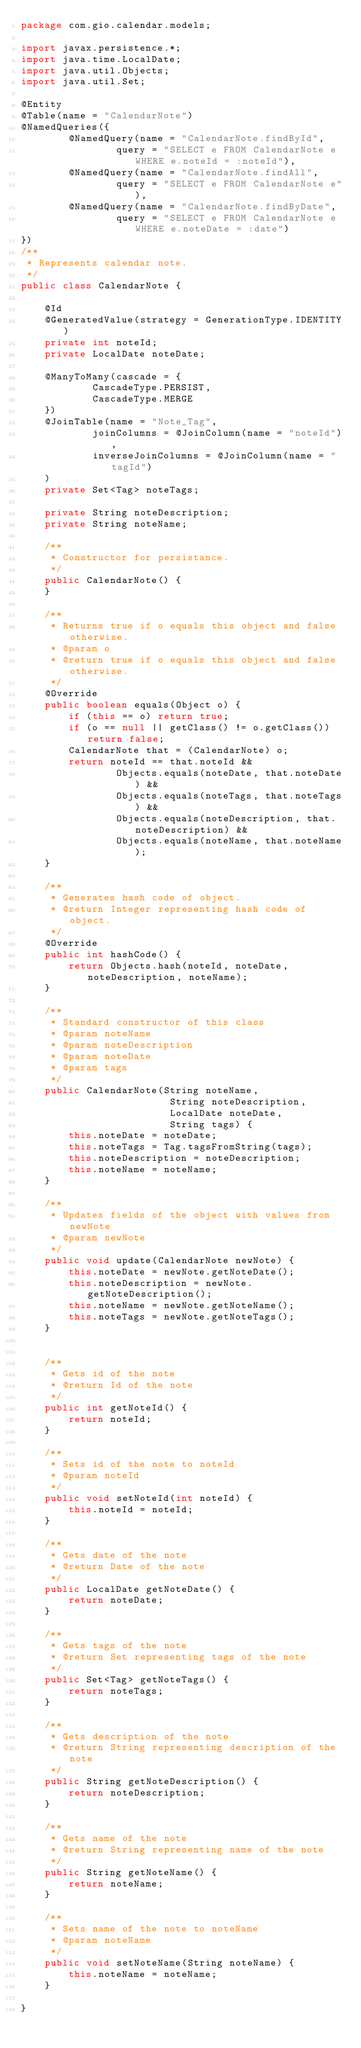Convert code to text. <code><loc_0><loc_0><loc_500><loc_500><_Java_>package com.gio.calendar.models;

import javax.persistence.*;
import java.time.LocalDate;
import java.util.Objects;
import java.util.Set;

@Entity
@Table(name = "CalendarNote")
@NamedQueries({
        @NamedQuery(name = "CalendarNote.findById",
                query = "SELECT e FROM CalendarNote e WHERE e.noteId = :noteId"),
        @NamedQuery(name = "CalendarNote.findAll",
                query = "SELECT e FROM CalendarNote e"),
        @NamedQuery(name = "CalendarNote.findByDate",
                query = "SELECT e FROM CalendarNote e WHERE e.noteDate = :date")
})
/**
 * Represents calendar note.
 */
public class CalendarNote {

    @Id
    @GeneratedValue(strategy = GenerationType.IDENTITY)
    private int noteId;
    private LocalDate noteDate;

    @ManyToMany(cascade = {
            CascadeType.PERSIST,
            CascadeType.MERGE
    })
    @JoinTable(name = "Note_Tag",
            joinColumns = @JoinColumn(name = "noteId"),
            inverseJoinColumns = @JoinColumn(name = "tagId")
    )
    private Set<Tag> noteTags;

    private String noteDescription;
    private String noteName;

    /**
     * Constructor for persistance.
     */
    public CalendarNote() {
    }

    /**
     * Returns true if o equals this object and false otherwise.
     * @param o
     * @return true if o equals this object and false otherwise.
     */
    @Override
    public boolean equals(Object o) {
        if (this == o) return true;
        if (o == null || getClass() != o.getClass()) return false;
        CalendarNote that = (CalendarNote) o;
        return noteId == that.noteId &&
                Objects.equals(noteDate, that.noteDate) &&
                Objects.equals(noteTags, that.noteTags) &&
                Objects.equals(noteDescription, that.noteDescription) &&
                Objects.equals(noteName, that.noteName);
    }

    /**
     * Generates hash code of object.
     * @return Integer representing hash code of object.
     */
    @Override
    public int hashCode() {
        return Objects.hash(noteId, noteDate, noteDescription, noteName);
    }

    /**
     * Standard constructor of this class
     * @param noteName
     * @param noteDescription
     * @param noteDate
     * @param tags
     */
    public CalendarNote(String noteName,
                         String noteDescription,
                         LocalDate noteDate,
                         String tags) {
        this.noteDate = noteDate;
        this.noteTags = Tag.tagsFromString(tags);
        this.noteDescription = noteDescription;
        this.noteName = noteName;
    }

    /**
     * Updates fields of the object with values from newNote
     * @param newNote
     */
    public void update(CalendarNote newNote) {
        this.noteDate = newNote.getNoteDate();
        this.noteDescription = newNote.getNoteDescription();
        this.noteName = newNote.getNoteName();
        this.noteTags = newNote.getNoteTags();
    }


    /**
     * Gets id of the note
     * @return Id of the note
     */
    public int getNoteId() {
        return noteId;
    }

    /**
     * Sets id of the note to noteId
     * @param noteId
     */
    public void setNoteId(int noteId) {
        this.noteId = noteId;
    }

    /**
     * Gets date of the note
     * @return Date of the note
     */
    public LocalDate getNoteDate() {
        return noteDate;
    }

    /**
     * Gets tags of the note
     * @return Set representing tags of the note
     */
    public Set<Tag> getNoteTags() {
        return noteTags;
    }

    /**
     * Gets description of the note
     * @return String representing description of the note
     */
    public String getNoteDescription() {
        return noteDescription;
    }

    /**
     * Gets name of the note
     * @return String representing name of the note
     */
    public String getNoteName() {
        return noteName;
    }

    /**
     * Sets name of the note to noteName
     * @param noteName
     */
    public void setNoteName(String noteName) {
        this.noteName = noteName;
    }

}
</code> 